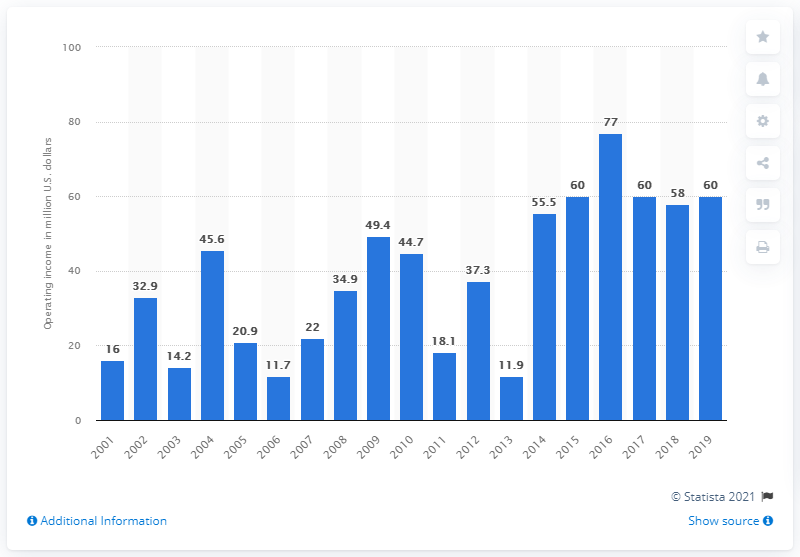Identify some key points in this picture. The operating income of the Cincinnati Bengals in the 2019 season was $60 million. 